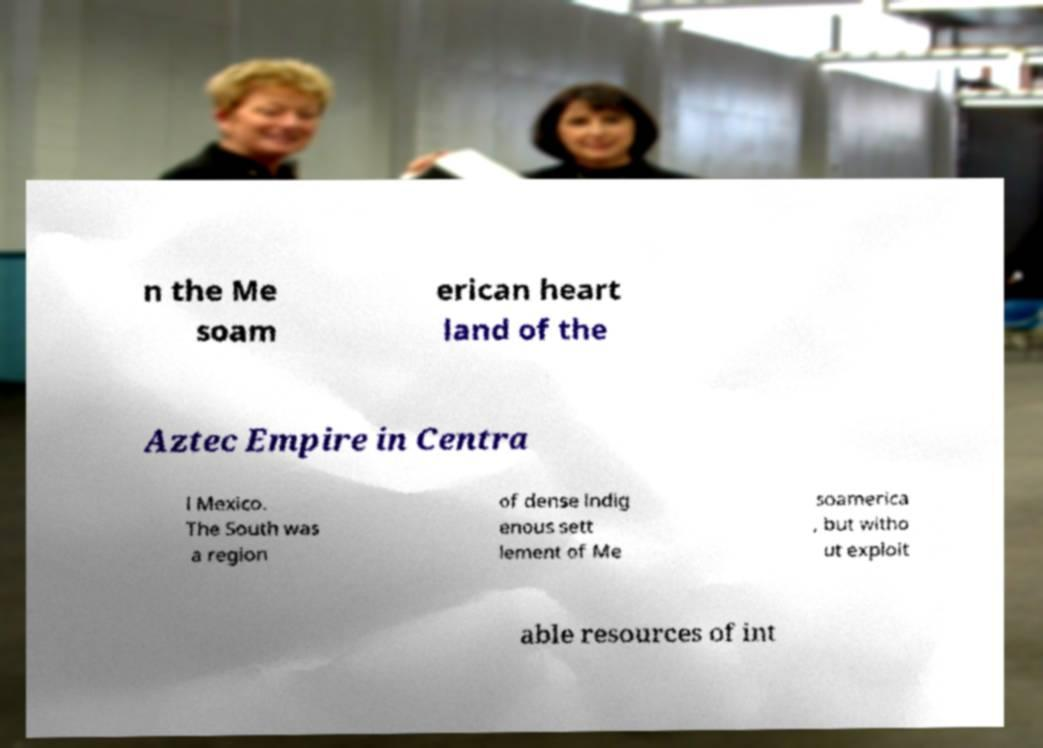Could you extract and type out the text from this image? n the Me soam erican heart land of the Aztec Empire in Centra l Mexico. The South was a region of dense indig enous sett lement of Me soamerica , but witho ut exploit able resources of int 